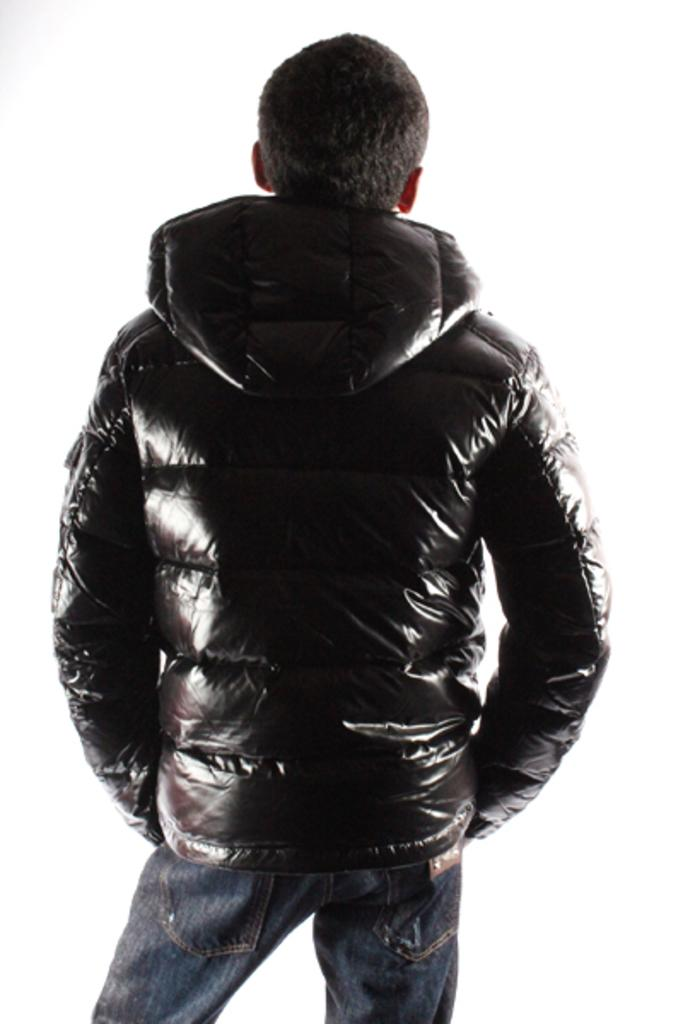Who is present in the image? There is a person in the image. What is the person doing in the image? The person is standing. What color is the jacket the person is wearing? The person is wearing a brown color jacket. What color are the pants the person is wearing? The person is wearing blue color pants. What color is the background of the image? The background of the image is white. How many sisters does the person in the image have? There is no information about the person's sisters in the image. Is there any dirt visible in the image? There is no dirt visible in the image. Can you see a rabbit in the image? There is no rabbit present in the image. 